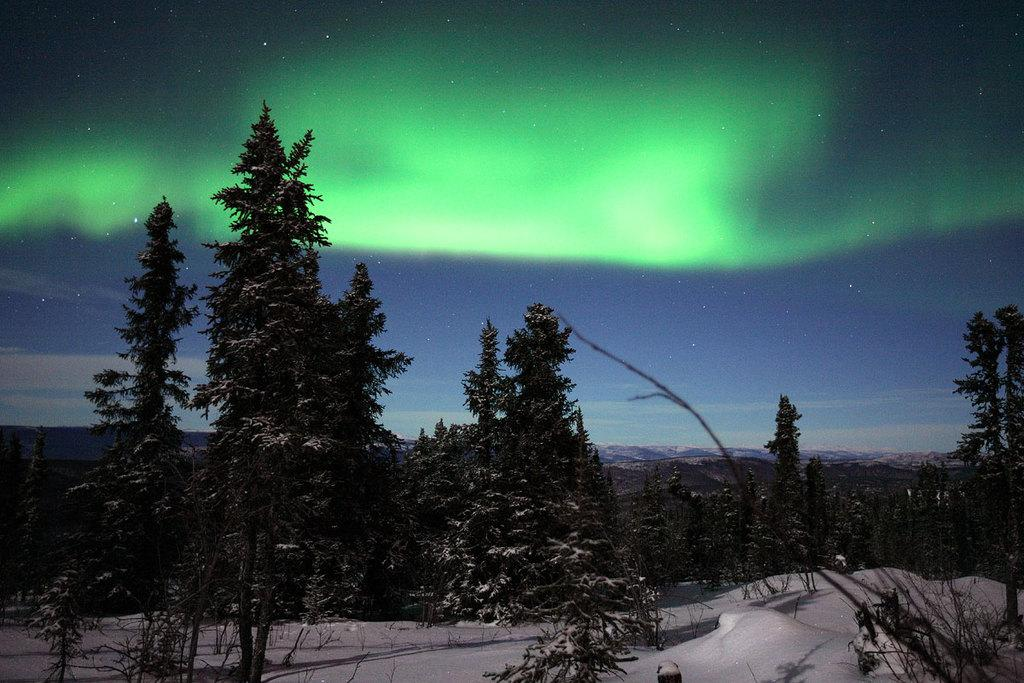What type of plant can be seen in the image? There is a tree in the image. What part of the natural environment is visible in the image? The sky is visible in the image. What is the color of the sky in the image? The sky is not green in color. Where is the tub located in the image? There is no tub present in the image. What type of activity is happening during the recess in the image? There is no recess or any activity mentioned in the image. 